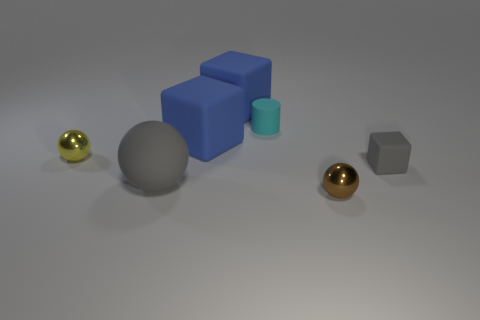Subtract all purple cylinders. How many blue cubes are left? 2 Subtract all metal spheres. How many spheres are left? 1 Add 1 big gray spheres. How many objects exist? 8 Subtract all purple balls. Subtract all cyan cylinders. How many balls are left? 3 Subtract all cylinders. How many objects are left? 6 Subtract all small yellow things. Subtract all gray rubber spheres. How many objects are left? 5 Add 7 cyan cylinders. How many cyan cylinders are left? 8 Add 1 tiny red things. How many tiny red things exist? 1 Subtract 1 brown spheres. How many objects are left? 6 